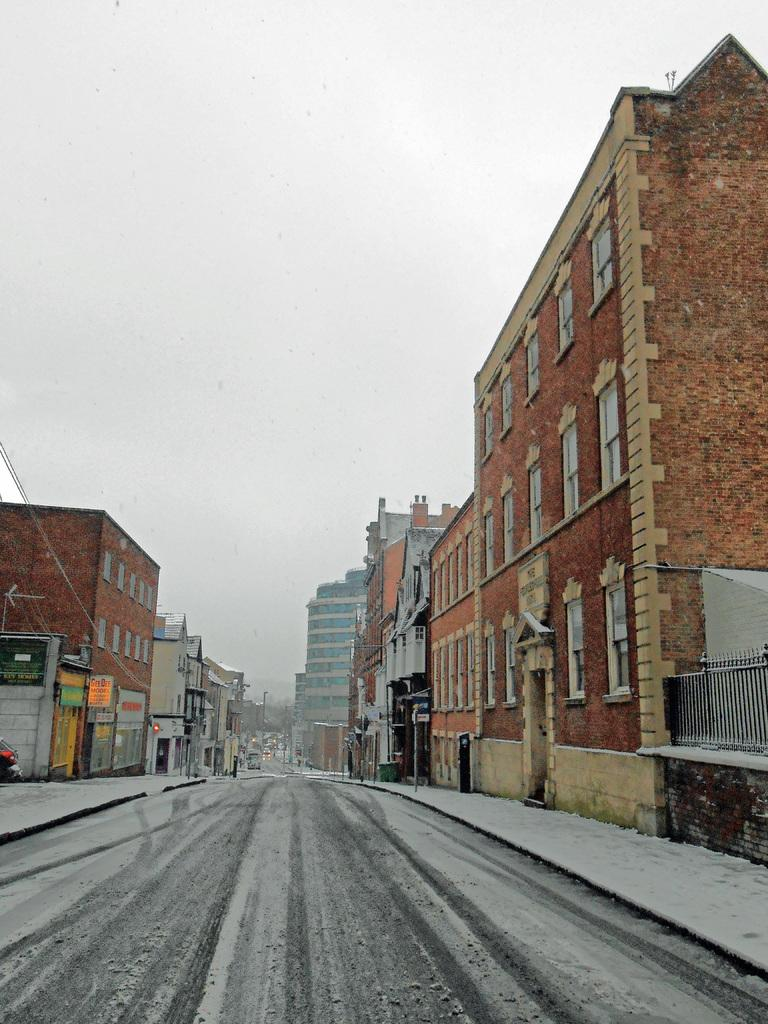What is the main feature in the middle of the image? There is a road in the middle of the image. What is covering the road? There is snow on the road. What can be seen on either side of the road? There are buildings on either side of the road. What is visible at the top of the image? The sky is visible at the top of the image. What type of sheet is covering the buildings in the image? There is no sheet covering the buildings in the image; they are visible with their original structures. 